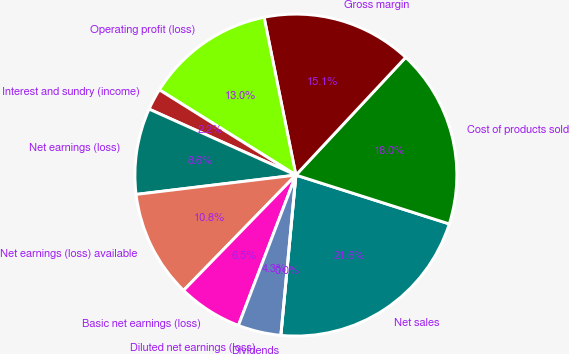Convert chart. <chart><loc_0><loc_0><loc_500><loc_500><pie_chart><fcel>Net sales<fcel>Cost of products sold<fcel>Gross margin<fcel>Operating profit (loss)<fcel>Interest and sundry (income)<fcel>Net earnings (loss)<fcel>Net earnings (loss) available<fcel>Basic net earnings (loss)<fcel>Diluted net earnings (loss)<fcel>Dividends<nl><fcel>21.58%<fcel>17.96%<fcel>15.11%<fcel>12.95%<fcel>2.16%<fcel>8.64%<fcel>10.79%<fcel>6.48%<fcel>4.32%<fcel>0.0%<nl></chart> 